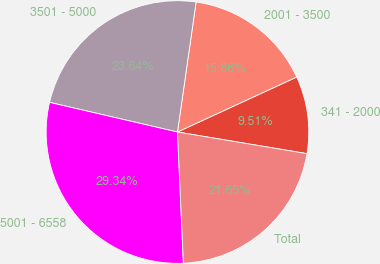Convert chart to OTSL. <chart><loc_0><loc_0><loc_500><loc_500><pie_chart><fcel>341 - 2000<fcel>2001 - 3500<fcel>3501 - 5000<fcel>5001 - 6558<fcel>Total<nl><fcel>9.51%<fcel>15.86%<fcel>23.64%<fcel>29.34%<fcel>21.65%<nl></chart> 